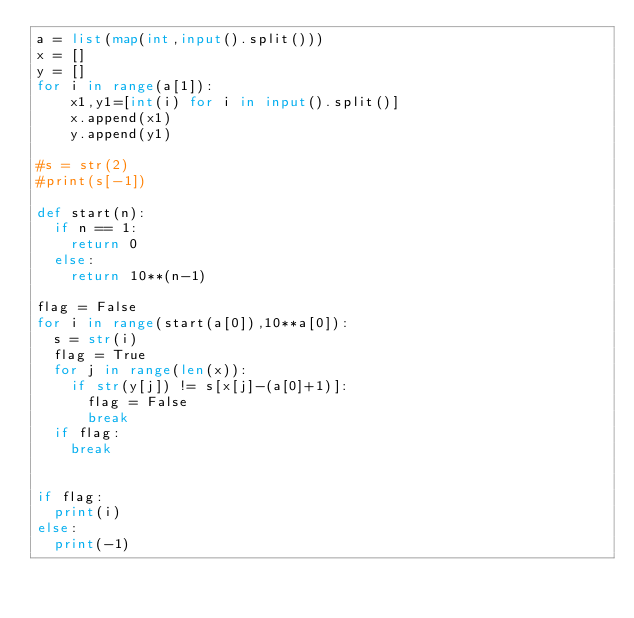Convert code to text. <code><loc_0><loc_0><loc_500><loc_500><_Python_>a = list(map(int,input().split()))
x = []
y = []
for i in range(a[1]):
    x1,y1=[int(i) for i in input().split()]
    x.append(x1)
    y.append(y1)
 
#s = str(2)
#print(s[-1])

def start(n):
  if n == 1:
    return 0
  else:
    return 10**(n-1)
    
flag = False
for i in range(start(a[0]),10**a[0]):
  s = str(i)
  flag = True
  for j in range(len(x)):
    if str(y[j]) != s[x[j]-(a[0]+1)]:
      flag = False
      break
  if flag:
    break
      

if flag:
  print(i)
else:
  print(-1)</code> 